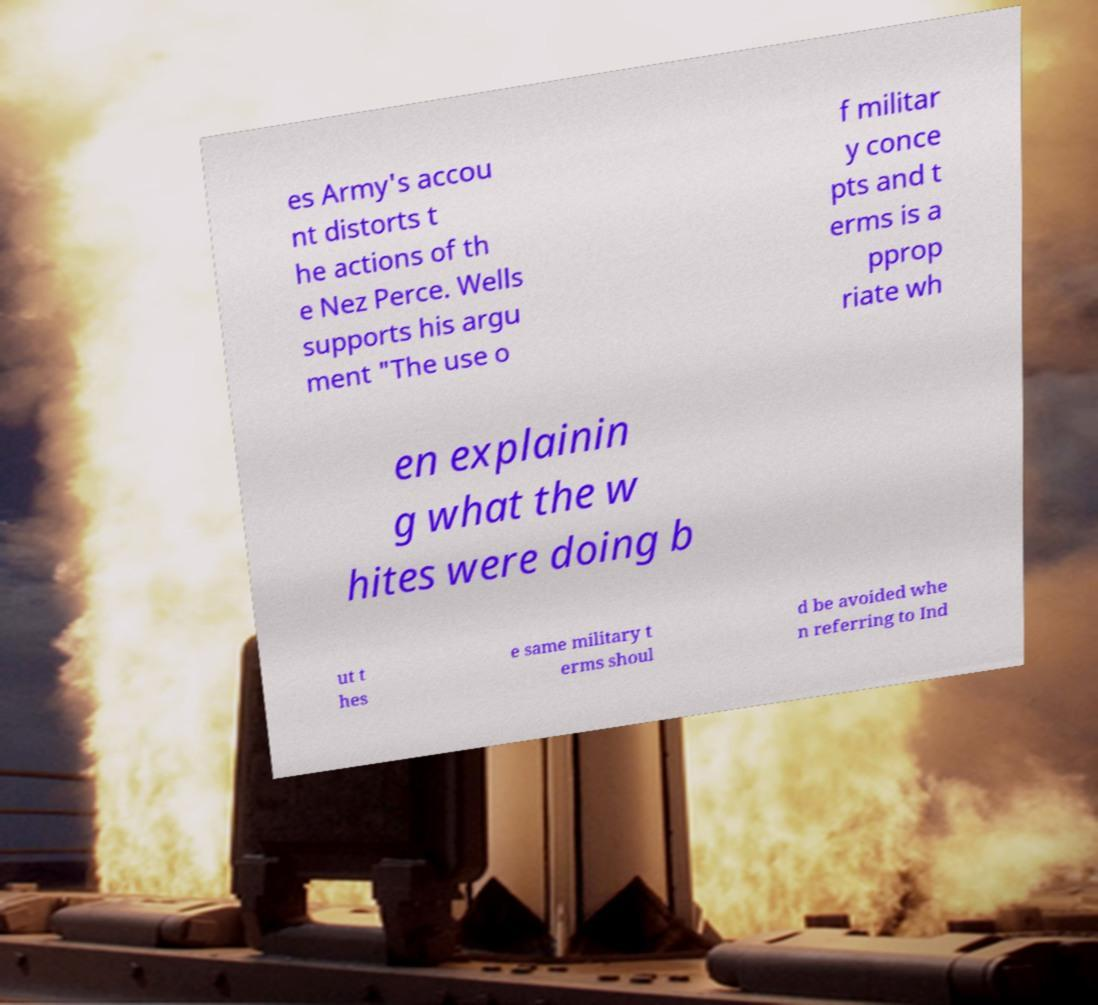Can you read and provide the text displayed in the image?This photo seems to have some interesting text. Can you extract and type it out for me? es Army's accou nt distorts t he actions of th e Nez Perce. Wells supports his argu ment "The use o f militar y conce pts and t erms is a pprop riate wh en explainin g what the w hites were doing b ut t hes e same military t erms shoul d be avoided whe n referring to Ind 